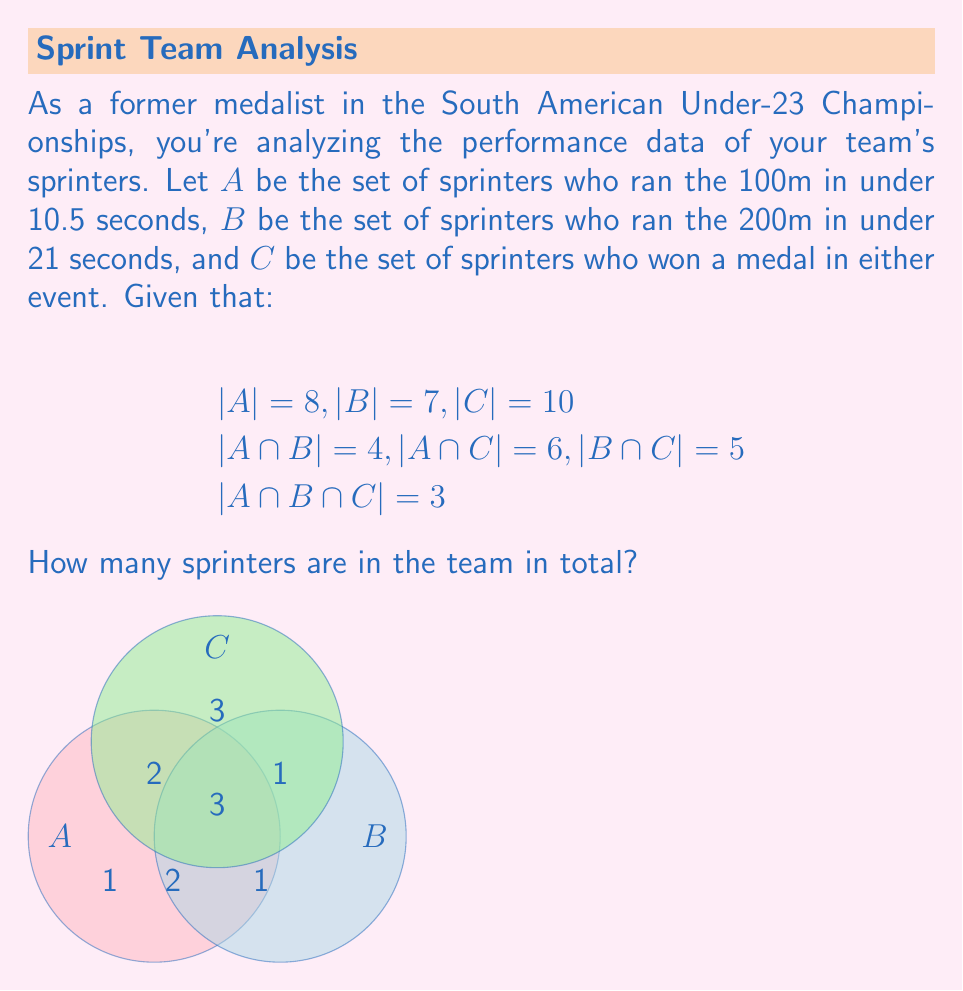Can you solve this math problem? Let's approach this step-by-step using set theory:

1) First, we need to understand what each intersection represents:
   $|A \cap B \cap C| = 3$ (sprinters in all three sets)
   $|A \cap B| - |A \cap B \cap C| = 4 - 3 = 1$ (sprinters in A and B but not C)
   $|A \cap C| - |A \cap B \cap C| = 6 - 3 = 3$ (sprinters in A and C but not B)
   $|B \cap C| - |A \cap B \cap C| = 5 - 3 = 2$ (sprinters in B and C but not A)

2) Now, let's calculate the number of sprinters in each set exclusively:
   $|A| - |A \cap B| - |A \cap C| + |A \cap B \cap C| = 8 - 4 - 6 + 3 = 1$
   $|B| - |A \cap B| - |B \cap C| + |A \cap B \cap C| = 7 - 4 - 5 + 3 = 1$
   $|C| - |A \cap C| - |B \cap C| + |A \cap B \cap C| = 10 - 6 - 5 + 3 = 2$

3) We can now use the inclusion-exclusion principle to find the total number of sprinters:
   
   $|A \cup B \cup C| = |A| + |B| + |C| - |A \cap B| - |A \cap C| - |B \cap C| + |A \cap B \cap C|$

4) Substituting the values:
   
   $|A \cup B \cup C| = 8 + 7 + 10 - 4 - 6 - 5 + 3 = 13$

Therefore, the team has 13 sprinters in total.
Answer: 13 sprinters 